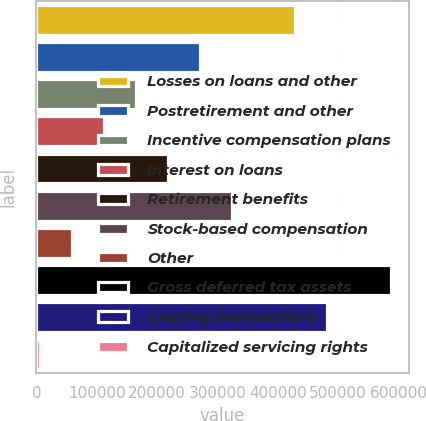Convert chart to OTSL. <chart><loc_0><loc_0><loc_500><loc_500><bar_chart><fcel>Losses on loans and other<fcel>Postretirement and other<fcel>Incentive compensation plans<fcel>Interest on loans<fcel>Retirement benefits<fcel>Stock-based compensation<fcel>Other<fcel>Gross deferred tax assets<fcel>Leasing transactions<fcel>Capitalized servicing rights<nl><fcel>429124<fcel>270464<fcel>164691<fcel>111804<fcel>217577<fcel>323351<fcel>58917.6<fcel>587784<fcel>482010<fcel>6031<nl></chart> 